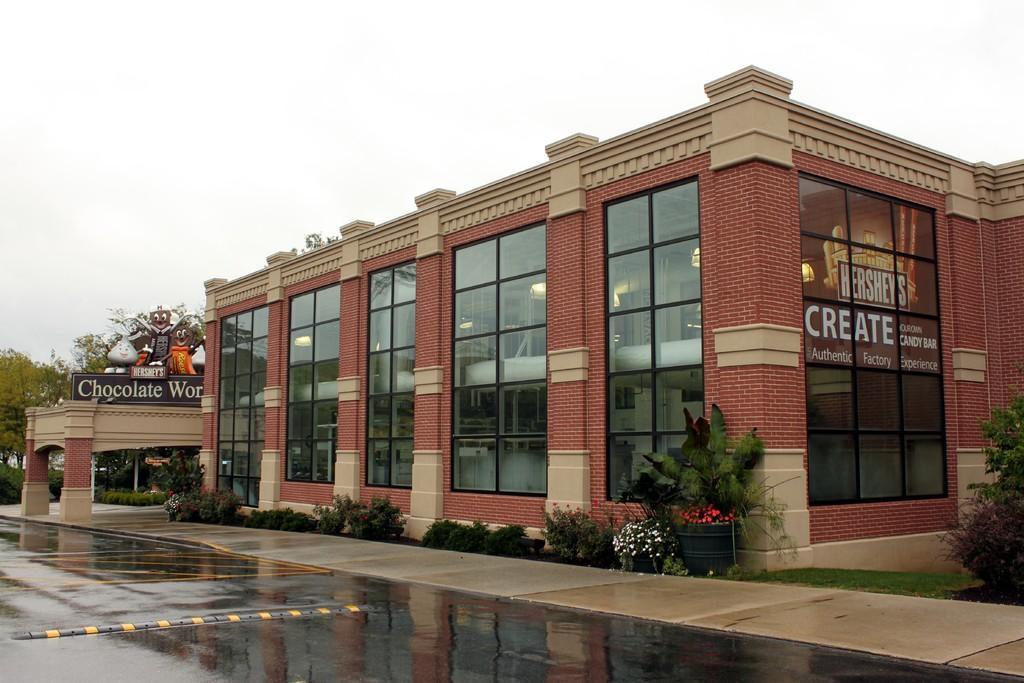Can you describe this image briefly? This image is clicked outside. There is building in the middle. There are bushes in the middle. There are trees on the left side. There is sky at the top. 